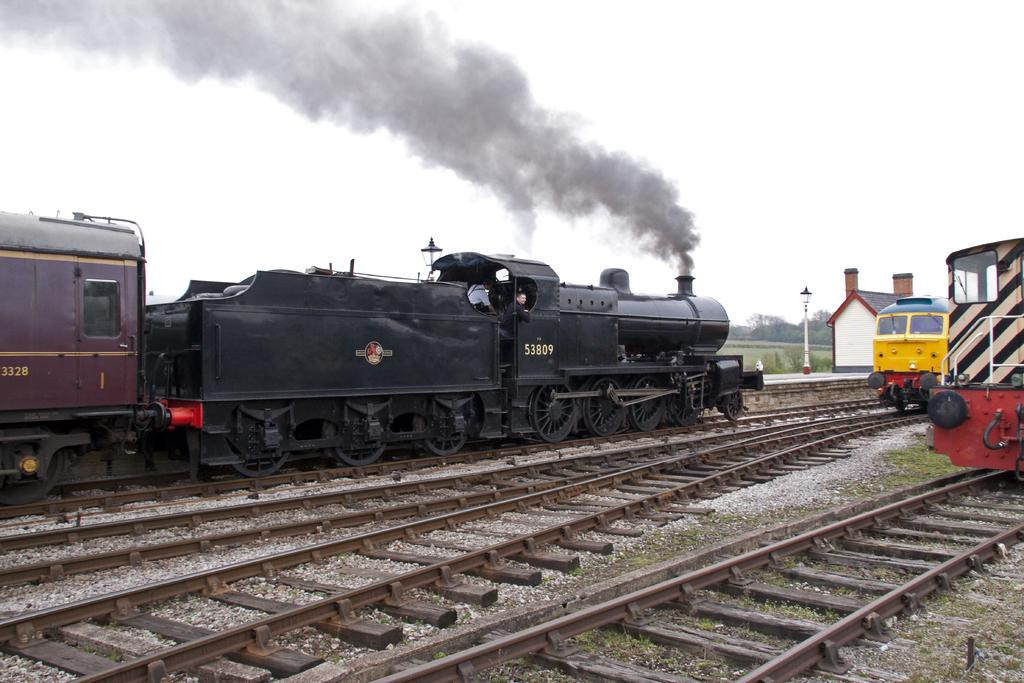What is the main subject of the image? The main subject of the image is a train. Where is the train located in the image? The train is on a train track. What type of vegetation can be seen in the image? There is grass visible in the image. What is the train emitting in the image? There is smoke in the image. What type of ground surface is present in the image? Stones are present in the image. What type of structure is visible in the image? There is a light pole in the image. What type of plant is visible in the image? There is a tree in the image. What is visible in the background of the image? The sky is visible in the image. What type of drink is being served in the image? There is no drink being served in the image; it features a train on a train track. What type of worm can be seen crawling on the train in the image? There are no worms present in the image; it features a train on a train track. 